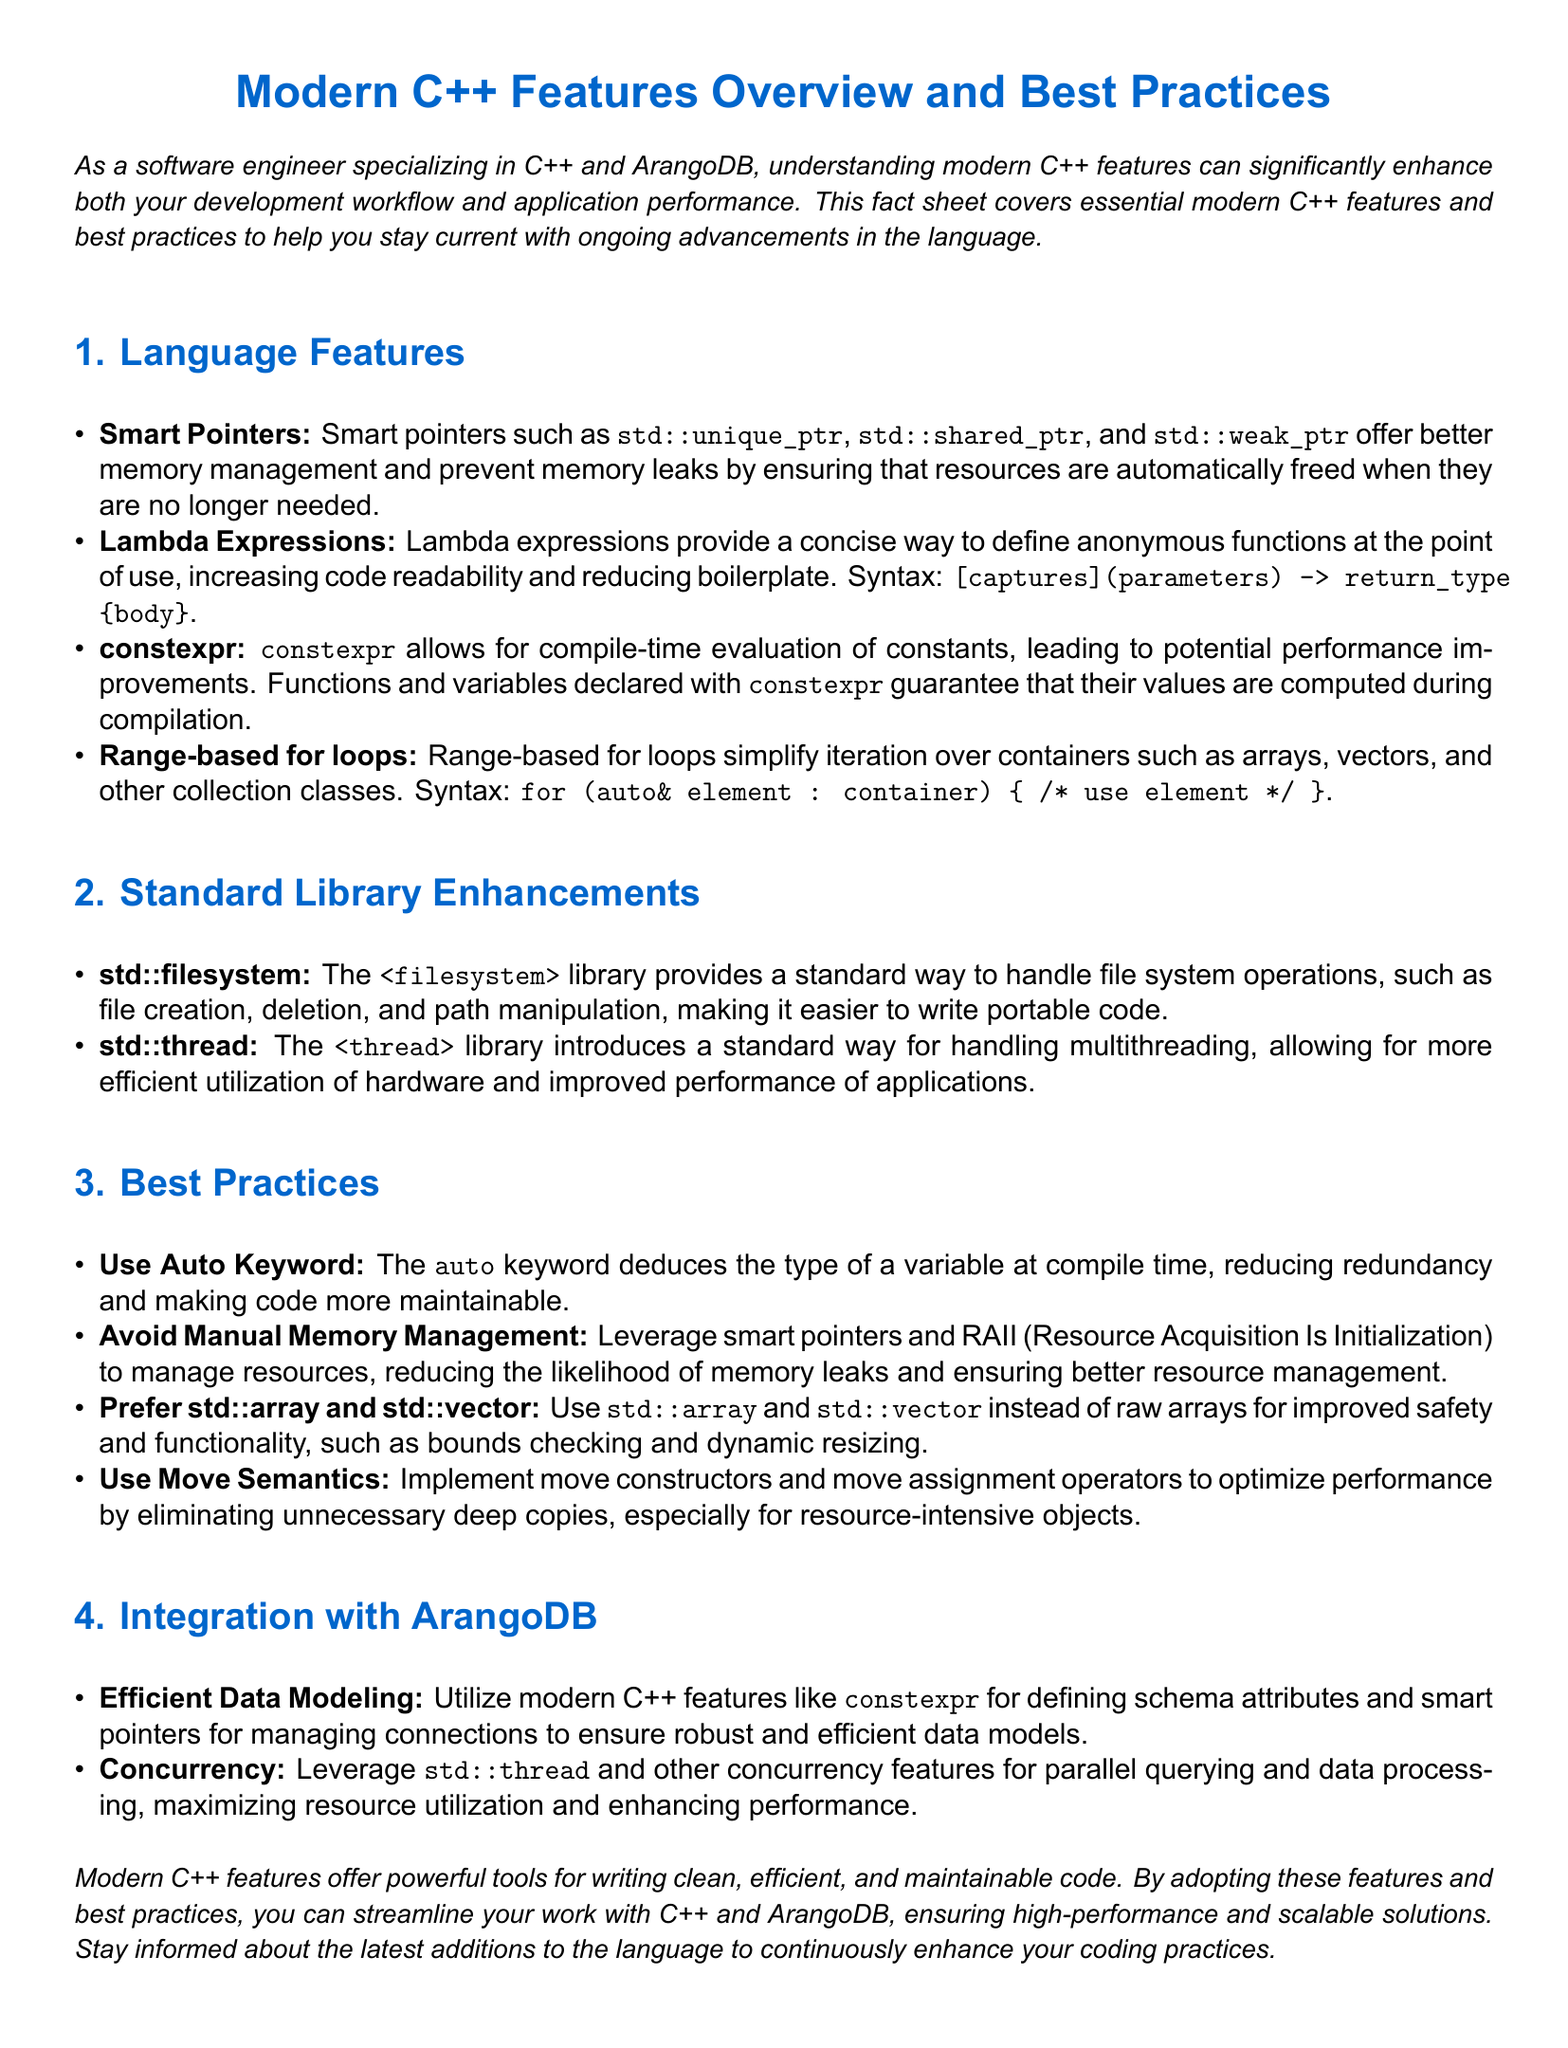What are the three types of smart pointers mentioned? The document lists std::unique_ptr, std::shared_ptr, and std::weak_ptr as the types of smart pointers.
Answer: std::unique_ptr, std::shared_ptr, std::weak_ptr What does constexpr allow in C++? The document states that constexpr allows for compile-time evaluation of constants.
Answer: Compile-time evaluation of constants What is one benefit of using lambda expressions? The document highlights that lambda expressions increase code readability.
Answer: Code readability Which library supports multithreading in modern C++? The document mentions the <thread> library as the one that supports multithreading.
Answer: <thread> library What is the preferred alternative to raw arrays according to best practices? The document recommends using std::array and std::vector instead of raw arrays.
Answer: std::array and std::vector How can modern C++ features benefit data processing in ArangoDB? The document explains that concurrency features can maximize resource utilization and enhance performance.
Answer: Maximize resource utilization and enhance performance What does the use of move semantics optimize? According to the document, move semantics optimize performance by eliminating unnecessary deep copies.
Answer: Performance optimization What type of document is this? The document is categorized as a fact sheet focused on modern C++ features and best practices.
Answer: Fact sheet 